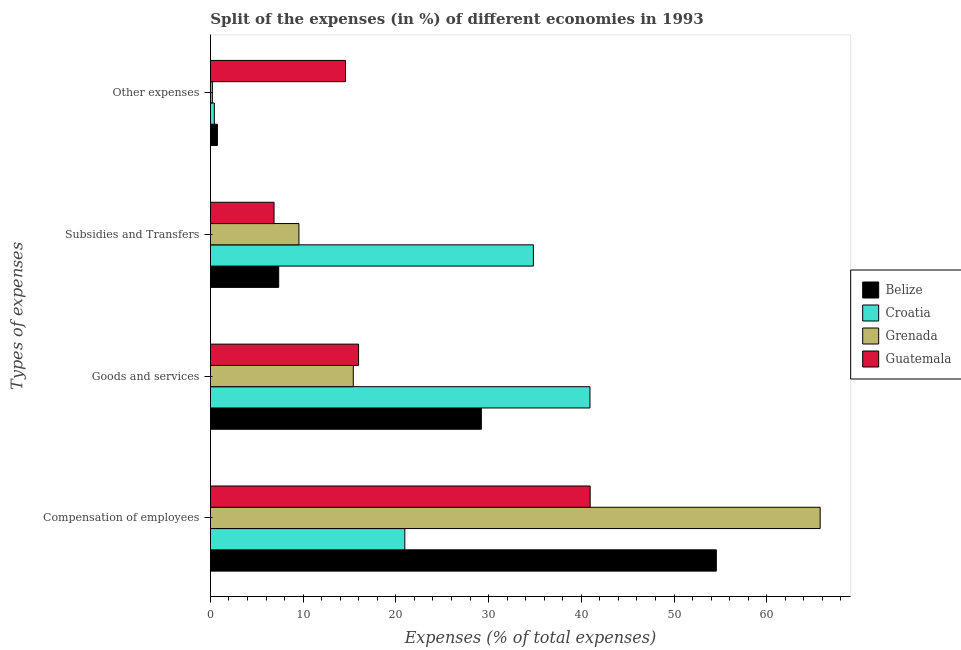How many different coloured bars are there?
Provide a short and direct response. 4. How many groups of bars are there?
Your answer should be very brief. 4. Are the number of bars on each tick of the Y-axis equal?
Offer a terse response. Yes. How many bars are there on the 4th tick from the top?
Your answer should be compact. 4. What is the label of the 3rd group of bars from the top?
Keep it short and to the point. Goods and services. What is the percentage of amount spent on subsidies in Guatemala?
Offer a very short reply. 6.87. Across all countries, what is the maximum percentage of amount spent on goods and services?
Provide a short and direct response. 40.94. Across all countries, what is the minimum percentage of amount spent on compensation of employees?
Offer a very short reply. 20.97. In which country was the percentage of amount spent on subsidies maximum?
Offer a terse response. Croatia. In which country was the percentage of amount spent on other expenses minimum?
Make the answer very short. Grenada. What is the total percentage of amount spent on other expenses in the graph?
Ensure brevity in your answer.  15.97. What is the difference between the percentage of amount spent on other expenses in Croatia and that in Belize?
Offer a terse response. -0.33. What is the difference between the percentage of amount spent on subsidies in Belize and the percentage of amount spent on goods and services in Guatemala?
Offer a very short reply. -8.61. What is the average percentage of amount spent on subsidies per country?
Ensure brevity in your answer.  14.65. What is the difference between the percentage of amount spent on compensation of employees and percentage of amount spent on goods and services in Grenada?
Ensure brevity in your answer.  50.35. In how many countries, is the percentage of amount spent on compensation of employees greater than 6 %?
Provide a short and direct response. 4. What is the ratio of the percentage of amount spent on goods and services in Croatia to that in Belize?
Offer a very short reply. 1.4. Is the percentage of amount spent on goods and services in Croatia less than that in Belize?
Make the answer very short. No. What is the difference between the highest and the second highest percentage of amount spent on subsidies?
Offer a very short reply. 25.29. What is the difference between the highest and the lowest percentage of amount spent on compensation of employees?
Make the answer very short. 44.8. Is it the case that in every country, the sum of the percentage of amount spent on compensation of employees and percentage of amount spent on other expenses is greater than the sum of percentage of amount spent on goods and services and percentage of amount spent on subsidies?
Make the answer very short. Yes. What does the 2nd bar from the top in Subsidies and Transfers represents?
Offer a terse response. Grenada. What does the 3rd bar from the bottom in Compensation of employees represents?
Offer a terse response. Grenada. Are all the bars in the graph horizontal?
Provide a succinct answer. Yes. How many countries are there in the graph?
Keep it short and to the point. 4. Does the graph contain any zero values?
Keep it short and to the point. No. Where does the legend appear in the graph?
Offer a very short reply. Center right. How many legend labels are there?
Offer a terse response. 4. How are the legend labels stacked?
Make the answer very short. Vertical. What is the title of the graph?
Your answer should be very brief. Split of the expenses (in %) of different economies in 1993. What is the label or title of the X-axis?
Offer a terse response. Expenses (% of total expenses). What is the label or title of the Y-axis?
Provide a short and direct response. Types of expenses. What is the Expenses (% of total expenses) of Belize in Compensation of employees?
Provide a succinct answer. 54.57. What is the Expenses (% of total expenses) in Croatia in Compensation of employees?
Make the answer very short. 20.97. What is the Expenses (% of total expenses) in Grenada in Compensation of employees?
Offer a terse response. 65.76. What is the Expenses (% of total expenses) in Guatemala in Compensation of employees?
Give a very brief answer. 40.96. What is the Expenses (% of total expenses) in Belize in Goods and services?
Provide a short and direct response. 29.22. What is the Expenses (% of total expenses) in Croatia in Goods and services?
Offer a very short reply. 40.94. What is the Expenses (% of total expenses) in Grenada in Goods and services?
Your answer should be very brief. 15.41. What is the Expenses (% of total expenses) of Guatemala in Goods and services?
Offer a very short reply. 15.98. What is the Expenses (% of total expenses) in Belize in Subsidies and Transfers?
Ensure brevity in your answer.  7.37. What is the Expenses (% of total expenses) in Croatia in Subsidies and Transfers?
Your answer should be compact. 34.84. What is the Expenses (% of total expenses) of Grenada in Subsidies and Transfers?
Keep it short and to the point. 9.55. What is the Expenses (% of total expenses) in Guatemala in Subsidies and Transfers?
Provide a short and direct response. 6.87. What is the Expenses (% of total expenses) of Belize in Other expenses?
Your answer should be compact. 0.76. What is the Expenses (% of total expenses) of Croatia in Other expenses?
Offer a terse response. 0.43. What is the Expenses (% of total expenses) in Grenada in Other expenses?
Your response must be concise. 0.21. What is the Expenses (% of total expenses) in Guatemala in Other expenses?
Your answer should be compact. 14.58. Across all Types of expenses, what is the maximum Expenses (% of total expenses) in Belize?
Keep it short and to the point. 54.57. Across all Types of expenses, what is the maximum Expenses (% of total expenses) in Croatia?
Your response must be concise. 40.94. Across all Types of expenses, what is the maximum Expenses (% of total expenses) of Grenada?
Make the answer very short. 65.76. Across all Types of expenses, what is the maximum Expenses (% of total expenses) of Guatemala?
Give a very brief answer. 40.96. Across all Types of expenses, what is the minimum Expenses (% of total expenses) in Belize?
Your response must be concise. 0.76. Across all Types of expenses, what is the minimum Expenses (% of total expenses) of Croatia?
Make the answer very short. 0.43. Across all Types of expenses, what is the minimum Expenses (% of total expenses) of Grenada?
Ensure brevity in your answer.  0.21. Across all Types of expenses, what is the minimum Expenses (% of total expenses) of Guatemala?
Provide a succinct answer. 6.87. What is the total Expenses (% of total expenses) of Belize in the graph?
Make the answer very short. 91.91. What is the total Expenses (% of total expenses) of Croatia in the graph?
Make the answer very short. 97.17. What is the total Expenses (% of total expenses) in Grenada in the graph?
Your response must be concise. 90.94. What is the total Expenses (% of total expenses) of Guatemala in the graph?
Offer a very short reply. 78.38. What is the difference between the Expenses (% of total expenses) in Belize in Compensation of employees and that in Goods and services?
Keep it short and to the point. 25.34. What is the difference between the Expenses (% of total expenses) in Croatia in Compensation of employees and that in Goods and services?
Your response must be concise. -19.97. What is the difference between the Expenses (% of total expenses) in Grenada in Compensation of employees and that in Goods and services?
Offer a very short reply. 50.35. What is the difference between the Expenses (% of total expenses) of Guatemala in Compensation of employees and that in Goods and services?
Offer a terse response. 24.98. What is the difference between the Expenses (% of total expenses) in Belize in Compensation of employees and that in Subsidies and Transfers?
Provide a succinct answer. 47.2. What is the difference between the Expenses (% of total expenses) of Croatia in Compensation of employees and that in Subsidies and Transfers?
Make the answer very short. -13.87. What is the difference between the Expenses (% of total expenses) of Grenada in Compensation of employees and that in Subsidies and Transfers?
Ensure brevity in your answer.  56.21. What is the difference between the Expenses (% of total expenses) of Guatemala in Compensation of employees and that in Subsidies and Transfers?
Give a very brief answer. 34.09. What is the difference between the Expenses (% of total expenses) in Belize in Compensation of employees and that in Other expenses?
Your answer should be very brief. 53.81. What is the difference between the Expenses (% of total expenses) in Croatia in Compensation of employees and that in Other expenses?
Your answer should be very brief. 20.54. What is the difference between the Expenses (% of total expenses) of Grenada in Compensation of employees and that in Other expenses?
Provide a succinct answer. 65.55. What is the difference between the Expenses (% of total expenses) in Guatemala in Compensation of employees and that in Other expenses?
Keep it short and to the point. 26.38. What is the difference between the Expenses (% of total expenses) of Belize in Goods and services and that in Subsidies and Transfers?
Make the answer very short. 21.85. What is the difference between the Expenses (% of total expenses) in Croatia in Goods and services and that in Subsidies and Transfers?
Your response must be concise. 6.1. What is the difference between the Expenses (% of total expenses) of Grenada in Goods and services and that in Subsidies and Transfers?
Your answer should be compact. 5.86. What is the difference between the Expenses (% of total expenses) in Guatemala in Goods and services and that in Subsidies and Transfers?
Offer a terse response. 9.12. What is the difference between the Expenses (% of total expenses) in Belize in Goods and services and that in Other expenses?
Ensure brevity in your answer.  28.47. What is the difference between the Expenses (% of total expenses) of Croatia in Goods and services and that in Other expenses?
Your answer should be very brief. 40.51. What is the difference between the Expenses (% of total expenses) of Grenada in Goods and services and that in Other expenses?
Provide a short and direct response. 15.2. What is the difference between the Expenses (% of total expenses) of Guatemala in Goods and services and that in Other expenses?
Give a very brief answer. 1.41. What is the difference between the Expenses (% of total expenses) of Belize in Subsidies and Transfers and that in Other expenses?
Provide a short and direct response. 6.61. What is the difference between the Expenses (% of total expenses) in Croatia in Subsidies and Transfers and that in Other expenses?
Your answer should be very brief. 34.41. What is the difference between the Expenses (% of total expenses) of Grenada in Subsidies and Transfers and that in Other expenses?
Ensure brevity in your answer.  9.34. What is the difference between the Expenses (% of total expenses) of Guatemala in Subsidies and Transfers and that in Other expenses?
Your answer should be compact. -7.71. What is the difference between the Expenses (% of total expenses) in Belize in Compensation of employees and the Expenses (% of total expenses) in Croatia in Goods and services?
Offer a very short reply. 13.63. What is the difference between the Expenses (% of total expenses) of Belize in Compensation of employees and the Expenses (% of total expenses) of Grenada in Goods and services?
Provide a succinct answer. 39.15. What is the difference between the Expenses (% of total expenses) of Belize in Compensation of employees and the Expenses (% of total expenses) of Guatemala in Goods and services?
Offer a very short reply. 38.58. What is the difference between the Expenses (% of total expenses) in Croatia in Compensation of employees and the Expenses (% of total expenses) in Grenada in Goods and services?
Your answer should be very brief. 5.56. What is the difference between the Expenses (% of total expenses) of Croatia in Compensation of employees and the Expenses (% of total expenses) of Guatemala in Goods and services?
Your answer should be compact. 4.99. What is the difference between the Expenses (% of total expenses) in Grenada in Compensation of employees and the Expenses (% of total expenses) in Guatemala in Goods and services?
Your answer should be very brief. 49.78. What is the difference between the Expenses (% of total expenses) in Belize in Compensation of employees and the Expenses (% of total expenses) in Croatia in Subsidies and Transfers?
Make the answer very short. 19.73. What is the difference between the Expenses (% of total expenses) in Belize in Compensation of employees and the Expenses (% of total expenses) in Grenada in Subsidies and Transfers?
Offer a terse response. 45.02. What is the difference between the Expenses (% of total expenses) in Belize in Compensation of employees and the Expenses (% of total expenses) in Guatemala in Subsidies and Transfers?
Offer a terse response. 47.7. What is the difference between the Expenses (% of total expenses) of Croatia in Compensation of employees and the Expenses (% of total expenses) of Grenada in Subsidies and Transfers?
Keep it short and to the point. 11.42. What is the difference between the Expenses (% of total expenses) in Croatia in Compensation of employees and the Expenses (% of total expenses) in Guatemala in Subsidies and Transfers?
Keep it short and to the point. 14.1. What is the difference between the Expenses (% of total expenses) in Grenada in Compensation of employees and the Expenses (% of total expenses) in Guatemala in Subsidies and Transfers?
Ensure brevity in your answer.  58.9. What is the difference between the Expenses (% of total expenses) in Belize in Compensation of employees and the Expenses (% of total expenses) in Croatia in Other expenses?
Provide a short and direct response. 54.14. What is the difference between the Expenses (% of total expenses) of Belize in Compensation of employees and the Expenses (% of total expenses) of Grenada in Other expenses?
Offer a very short reply. 54.35. What is the difference between the Expenses (% of total expenses) in Belize in Compensation of employees and the Expenses (% of total expenses) in Guatemala in Other expenses?
Ensure brevity in your answer.  39.99. What is the difference between the Expenses (% of total expenses) in Croatia in Compensation of employees and the Expenses (% of total expenses) in Grenada in Other expenses?
Give a very brief answer. 20.76. What is the difference between the Expenses (% of total expenses) in Croatia in Compensation of employees and the Expenses (% of total expenses) in Guatemala in Other expenses?
Offer a very short reply. 6.39. What is the difference between the Expenses (% of total expenses) in Grenada in Compensation of employees and the Expenses (% of total expenses) in Guatemala in Other expenses?
Give a very brief answer. 51.19. What is the difference between the Expenses (% of total expenses) in Belize in Goods and services and the Expenses (% of total expenses) in Croatia in Subsidies and Transfers?
Your answer should be very brief. -5.61. What is the difference between the Expenses (% of total expenses) of Belize in Goods and services and the Expenses (% of total expenses) of Grenada in Subsidies and Transfers?
Provide a short and direct response. 19.67. What is the difference between the Expenses (% of total expenses) of Belize in Goods and services and the Expenses (% of total expenses) of Guatemala in Subsidies and Transfers?
Provide a succinct answer. 22.36. What is the difference between the Expenses (% of total expenses) of Croatia in Goods and services and the Expenses (% of total expenses) of Grenada in Subsidies and Transfers?
Provide a succinct answer. 31.39. What is the difference between the Expenses (% of total expenses) in Croatia in Goods and services and the Expenses (% of total expenses) in Guatemala in Subsidies and Transfers?
Provide a succinct answer. 34.07. What is the difference between the Expenses (% of total expenses) in Grenada in Goods and services and the Expenses (% of total expenses) in Guatemala in Subsidies and Transfers?
Ensure brevity in your answer.  8.55. What is the difference between the Expenses (% of total expenses) of Belize in Goods and services and the Expenses (% of total expenses) of Croatia in Other expenses?
Provide a succinct answer. 28.79. What is the difference between the Expenses (% of total expenses) in Belize in Goods and services and the Expenses (% of total expenses) in Grenada in Other expenses?
Ensure brevity in your answer.  29.01. What is the difference between the Expenses (% of total expenses) of Belize in Goods and services and the Expenses (% of total expenses) of Guatemala in Other expenses?
Offer a terse response. 14.65. What is the difference between the Expenses (% of total expenses) of Croatia in Goods and services and the Expenses (% of total expenses) of Grenada in Other expenses?
Ensure brevity in your answer.  40.73. What is the difference between the Expenses (% of total expenses) in Croatia in Goods and services and the Expenses (% of total expenses) in Guatemala in Other expenses?
Keep it short and to the point. 26.36. What is the difference between the Expenses (% of total expenses) in Grenada in Goods and services and the Expenses (% of total expenses) in Guatemala in Other expenses?
Offer a terse response. 0.84. What is the difference between the Expenses (% of total expenses) of Belize in Subsidies and Transfers and the Expenses (% of total expenses) of Croatia in Other expenses?
Provide a short and direct response. 6.94. What is the difference between the Expenses (% of total expenses) of Belize in Subsidies and Transfers and the Expenses (% of total expenses) of Grenada in Other expenses?
Your response must be concise. 7.16. What is the difference between the Expenses (% of total expenses) in Belize in Subsidies and Transfers and the Expenses (% of total expenses) in Guatemala in Other expenses?
Provide a short and direct response. -7.21. What is the difference between the Expenses (% of total expenses) of Croatia in Subsidies and Transfers and the Expenses (% of total expenses) of Grenada in Other expenses?
Offer a terse response. 34.62. What is the difference between the Expenses (% of total expenses) in Croatia in Subsidies and Transfers and the Expenses (% of total expenses) in Guatemala in Other expenses?
Provide a short and direct response. 20.26. What is the difference between the Expenses (% of total expenses) of Grenada in Subsidies and Transfers and the Expenses (% of total expenses) of Guatemala in Other expenses?
Your response must be concise. -5.03. What is the average Expenses (% of total expenses) of Belize per Types of expenses?
Ensure brevity in your answer.  22.98. What is the average Expenses (% of total expenses) of Croatia per Types of expenses?
Keep it short and to the point. 24.29. What is the average Expenses (% of total expenses) in Grenada per Types of expenses?
Offer a terse response. 22.73. What is the average Expenses (% of total expenses) in Guatemala per Types of expenses?
Offer a very short reply. 19.6. What is the difference between the Expenses (% of total expenses) of Belize and Expenses (% of total expenses) of Croatia in Compensation of employees?
Offer a terse response. 33.6. What is the difference between the Expenses (% of total expenses) in Belize and Expenses (% of total expenses) in Grenada in Compensation of employees?
Offer a terse response. -11.2. What is the difference between the Expenses (% of total expenses) of Belize and Expenses (% of total expenses) of Guatemala in Compensation of employees?
Provide a succinct answer. 13.61. What is the difference between the Expenses (% of total expenses) of Croatia and Expenses (% of total expenses) of Grenada in Compensation of employees?
Offer a terse response. -44.8. What is the difference between the Expenses (% of total expenses) of Croatia and Expenses (% of total expenses) of Guatemala in Compensation of employees?
Your answer should be compact. -19.99. What is the difference between the Expenses (% of total expenses) of Grenada and Expenses (% of total expenses) of Guatemala in Compensation of employees?
Your answer should be very brief. 24.81. What is the difference between the Expenses (% of total expenses) in Belize and Expenses (% of total expenses) in Croatia in Goods and services?
Keep it short and to the point. -11.72. What is the difference between the Expenses (% of total expenses) in Belize and Expenses (% of total expenses) in Grenada in Goods and services?
Keep it short and to the point. 13.81. What is the difference between the Expenses (% of total expenses) of Belize and Expenses (% of total expenses) of Guatemala in Goods and services?
Your answer should be very brief. 13.24. What is the difference between the Expenses (% of total expenses) in Croatia and Expenses (% of total expenses) in Grenada in Goods and services?
Ensure brevity in your answer.  25.53. What is the difference between the Expenses (% of total expenses) in Croatia and Expenses (% of total expenses) in Guatemala in Goods and services?
Ensure brevity in your answer.  24.96. What is the difference between the Expenses (% of total expenses) of Grenada and Expenses (% of total expenses) of Guatemala in Goods and services?
Keep it short and to the point. -0.57. What is the difference between the Expenses (% of total expenses) in Belize and Expenses (% of total expenses) in Croatia in Subsidies and Transfers?
Provide a short and direct response. -27.47. What is the difference between the Expenses (% of total expenses) of Belize and Expenses (% of total expenses) of Grenada in Subsidies and Transfers?
Your response must be concise. -2.18. What is the difference between the Expenses (% of total expenses) of Belize and Expenses (% of total expenses) of Guatemala in Subsidies and Transfers?
Offer a terse response. 0.5. What is the difference between the Expenses (% of total expenses) in Croatia and Expenses (% of total expenses) in Grenada in Subsidies and Transfers?
Your answer should be very brief. 25.29. What is the difference between the Expenses (% of total expenses) in Croatia and Expenses (% of total expenses) in Guatemala in Subsidies and Transfers?
Provide a succinct answer. 27.97. What is the difference between the Expenses (% of total expenses) in Grenada and Expenses (% of total expenses) in Guatemala in Subsidies and Transfers?
Offer a very short reply. 2.68. What is the difference between the Expenses (% of total expenses) in Belize and Expenses (% of total expenses) in Croatia in Other expenses?
Give a very brief answer. 0.33. What is the difference between the Expenses (% of total expenses) of Belize and Expenses (% of total expenses) of Grenada in Other expenses?
Give a very brief answer. 0.54. What is the difference between the Expenses (% of total expenses) of Belize and Expenses (% of total expenses) of Guatemala in Other expenses?
Provide a succinct answer. -13.82. What is the difference between the Expenses (% of total expenses) in Croatia and Expenses (% of total expenses) in Grenada in Other expenses?
Keep it short and to the point. 0.22. What is the difference between the Expenses (% of total expenses) of Croatia and Expenses (% of total expenses) of Guatemala in Other expenses?
Your response must be concise. -14.15. What is the difference between the Expenses (% of total expenses) in Grenada and Expenses (% of total expenses) in Guatemala in Other expenses?
Keep it short and to the point. -14.36. What is the ratio of the Expenses (% of total expenses) in Belize in Compensation of employees to that in Goods and services?
Provide a short and direct response. 1.87. What is the ratio of the Expenses (% of total expenses) in Croatia in Compensation of employees to that in Goods and services?
Provide a succinct answer. 0.51. What is the ratio of the Expenses (% of total expenses) in Grenada in Compensation of employees to that in Goods and services?
Offer a very short reply. 4.27. What is the ratio of the Expenses (% of total expenses) in Guatemala in Compensation of employees to that in Goods and services?
Your answer should be very brief. 2.56. What is the ratio of the Expenses (% of total expenses) of Belize in Compensation of employees to that in Subsidies and Transfers?
Ensure brevity in your answer.  7.41. What is the ratio of the Expenses (% of total expenses) of Croatia in Compensation of employees to that in Subsidies and Transfers?
Make the answer very short. 0.6. What is the ratio of the Expenses (% of total expenses) in Grenada in Compensation of employees to that in Subsidies and Transfers?
Your answer should be compact. 6.89. What is the ratio of the Expenses (% of total expenses) of Guatemala in Compensation of employees to that in Subsidies and Transfers?
Your answer should be compact. 5.97. What is the ratio of the Expenses (% of total expenses) in Belize in Compensation of employees to that in Other expenses?
Your response must be concise. 72.2. What is the ratio of the Expenses (% of total expenses) in Croatia in Compensation of employees to that in Other expenses?
Your answer should be compact. 49.05. What is the ratio of the Expenses (% of total expenses) in Grenada in Compensation of employees to that in Other expenses?
Give a very brief answer. 310.09. What is the ratio of the Expenses (% of total expenses) in Guatemala in Compensation of employees to that in Other expenses?
Keep it short and to the point. 2.81. What is the ratio of the Expenses (% of total expenses) in Belize in Goods and services to that in Subsidies and Transfers?
Give a very brief answer. 3.97. What is the ratio of the Expenses (% of total expenses) in Croatia in Goods and services to that in Subsidies and Transfers?
Keep it short and to the point. 1.18. What is the ratio of the Expenses (% of total expenses) in Grenada in Goods and services to that in Subsidies and Transfers?
Your answer should be compact. 1.61. What is the ratio of the Expenses (% of total expenses) of Guatemala in Goods and services to that in Subsidies and Transfers?
Ensure brevity in your answer.  2.33. What is the ratio of the Expenses (% of total expenses) in Belize in Goods and services to that in Other expenses?
Keep it short and to the point. 38.67. What is the ratio of the Expenses (% of total expenses) of Croatia in Goods and services to that in Other expenses?
Keep it short and to the point. 95.77. What is the ratio of the Expenses (% of total expenses) in Grenada in Goods and services to that in Other expenses?
Give a very brief answer. 72.67. What is the ratio of the Expenses (% of total expenses) in Guatemala in Goods and services to that in Other expenses?
Give a very brief answer. 1.1. What is the ratio of the Expenses (% of total expenses) in Belize in Subsidies and Transfers to that in Other expenses?
Offer a very short reply. 9.75. What is the ratio of the Expenses (% of total expenses) in Croatia in Subsidies and Transfers to that in Other expenses?
Your response must be concise. 81.49. What is the ratio of the Expenses (% of total expenses) of Grenada in Subsidies and Transfers to that in Other expenses?
Give a very brief answer. 45.03. What is the ratio of the Expenses (% of total expenses) of Guatemala in Subsidies and Transfers to that in Other expenses?
Give a very brief answer. 0.47. What is the difference between the highest and the second highest Expenses (% of total expenses) of Belize?
Offer a terse response. 25.34. What is the difference between the highest and the second highest Expenses (% of total expenses) of Croatia?
Ensure brevity in your answer.  6.1. What is the difference between the highest and the second highest Expenses (% of total expenses) of Grenada?
Your response must be concise. 50.35. What is the difference between the highest and the second highest Expenses (% of total expenses) in Guatemala?
Your answer should be very brief. 24.98. What is the difference between the highest and the lowest Expenses (% of total expenses) in Belize?
Make the answer very short. 53.81. What is the difference between the highest and the lowest Expenses (% of total expenses) in Croatia?
Keep it short and to the point. 40.51. What is the difference between the highest and the lowest Expenses (% of total expenses) in Grenada?
Your answer should be compact. 65.55. What is the difference between the highest and the lowest Expenses (% of total expenses) in Guatemala?
Offer a very short reply. 34.09. 